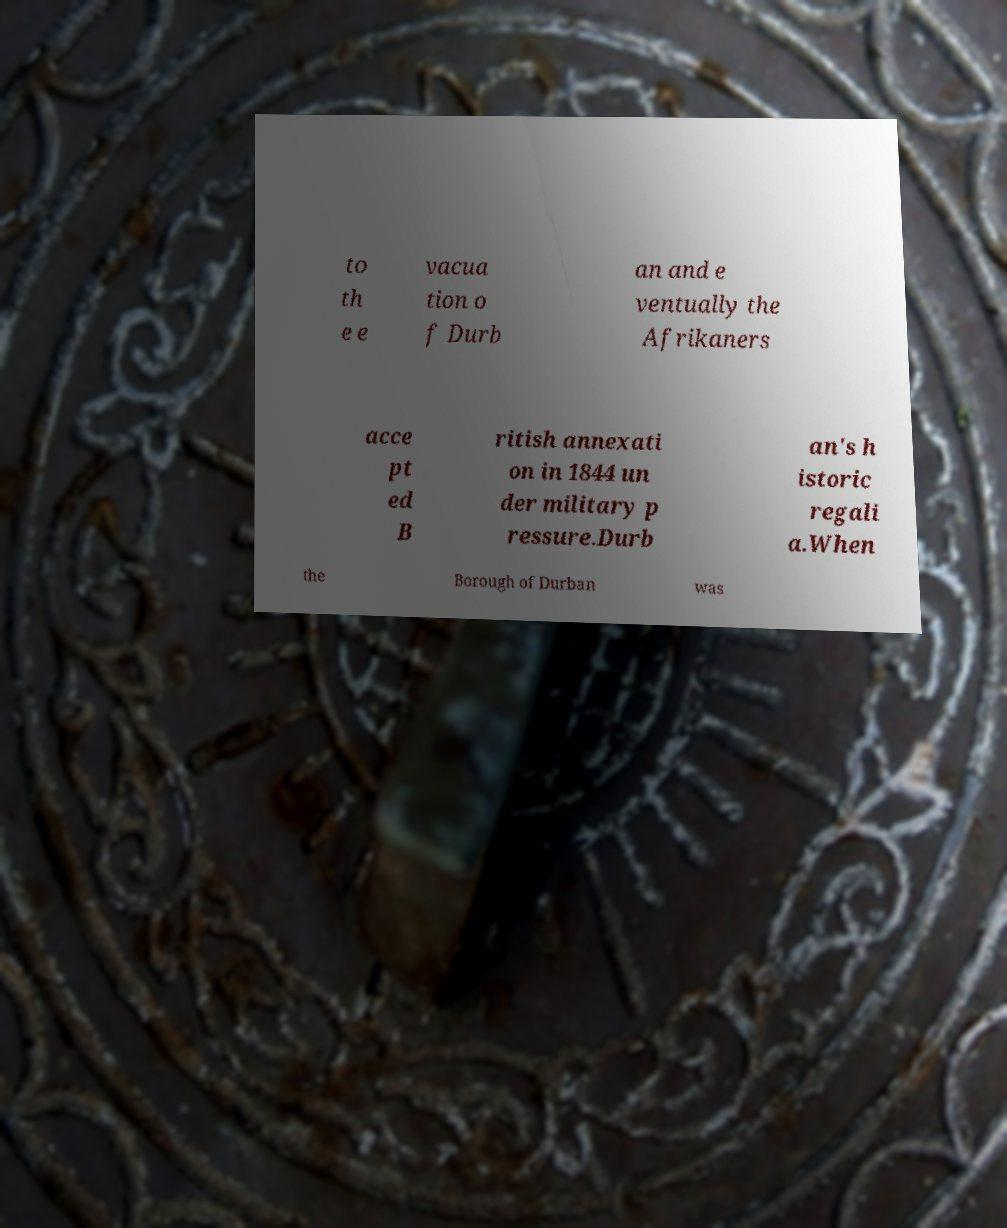Could you assist in decoding the text presented in this image and type it out clearly? to th e e vacua tion o f Durb an and e ventually the Afrikaners acce pt ed B ritish annexati on in 1844 un der military p ressure.Durb an's h istoric regali a.When the Borough of Durban was 